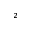<formula> <loc_0><loc_0><loc_500><loc_500>^ { 2 }</formula> 